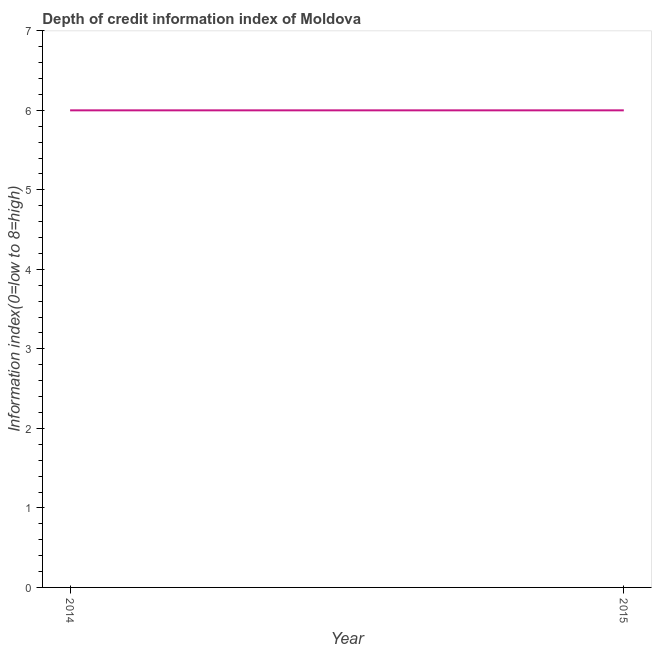Across all years, what is the minimum depth of credit information index?
Ensure brevity in your answer.  6. In which year was the depth of credit information index maximum?
Keep it short and to the point. 2014. What is the sum of the depth of credit information index?
Offer a very short reply. 12. What is the average depth of credit information index per year?
Offer a terse response. 6. Do a majority of the years between 2015 and 2014 (inclusive) have depth of credit information index greater than 3.4 ?
Provide a short and direct response. No. Is the depth of credit information index in 2014 less than that in 2015?
Keep it short and to the point. No. Does the depth of credit information index monotonically increase over the years?
Offer a very short reply. No. What is the difference between two consecutive major ticks on the Y-axis?
Your answer should be compact. 1. What is the title of the graph?
Provide a succinct answer. Depth of credit information index of Moldova. What is the label or title of the Y-axis?
Keep it short and to the point. Information index(0=low to 8=high). What is the difference between the Information index(0=low to 8=high) in 2014 and 2015?
Your response must be concise. 0. 